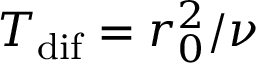Convert formula to latex. <formula><loc_0><loc_0><loc_500><loc_500>T _ { d i f } = r _ { 0 } ^ { 2 } / \nu</formula> 